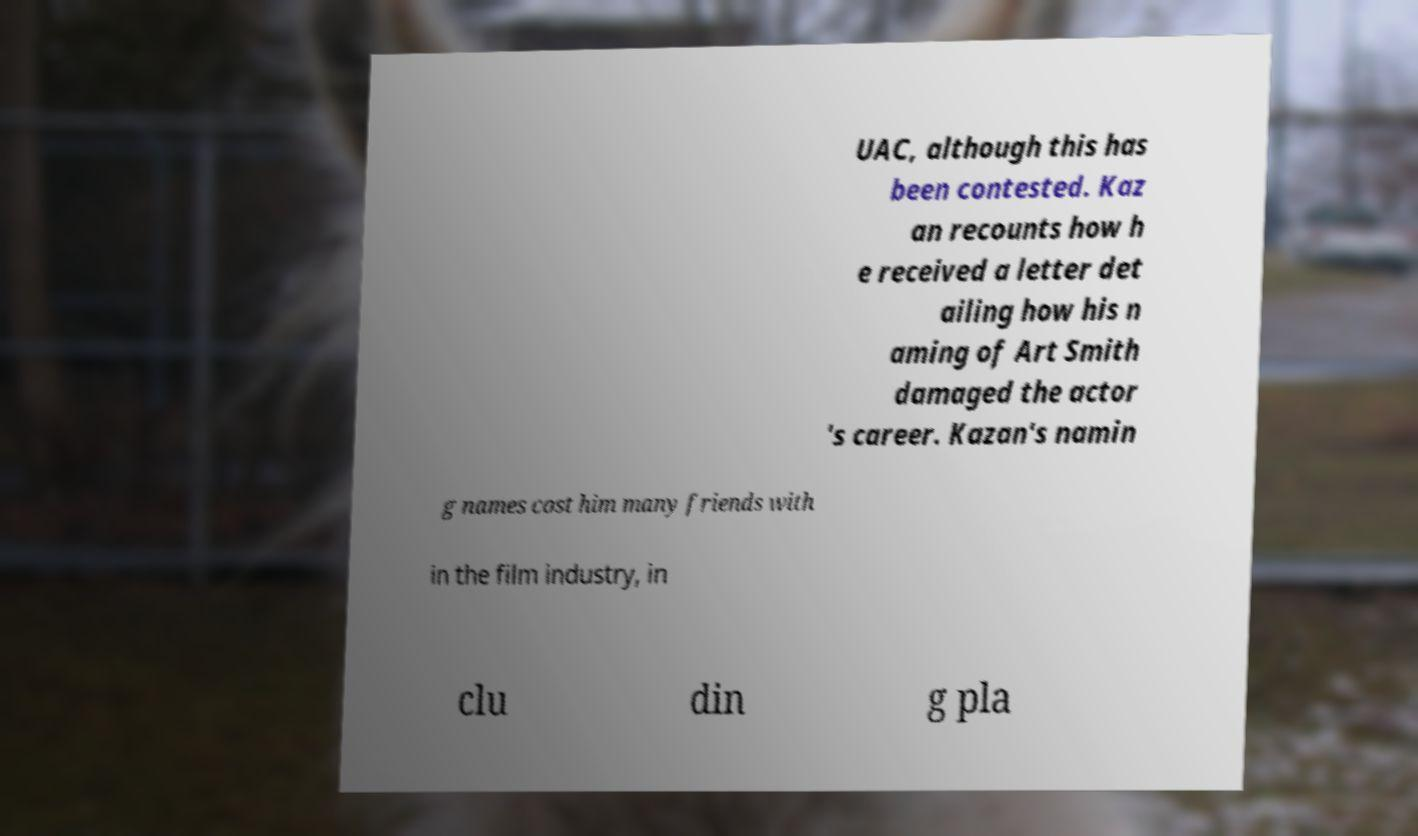For documentation purposes, I need the text within this image transcribed. Could you provide that? UAC, although this has been contested. Kaz an recounts how h e received a letter det ailing how his n aming of Art Smith damaged the actor 's career. Kazan's namin g names cost him many friends with in the film industry, in clu din g pla 